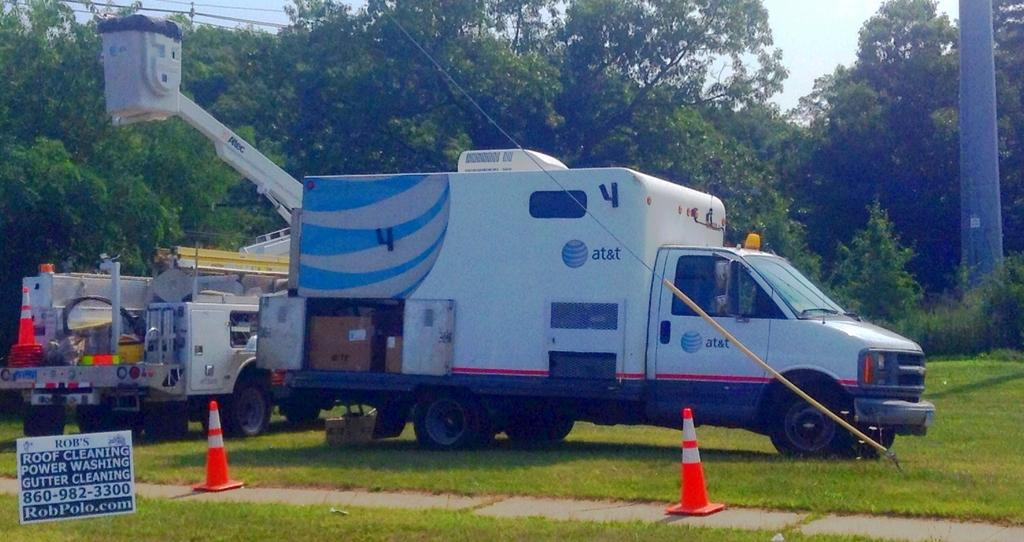<image>
Summarize the visual content of the image. An At&T truck sits in front of two orange traffic cones. 